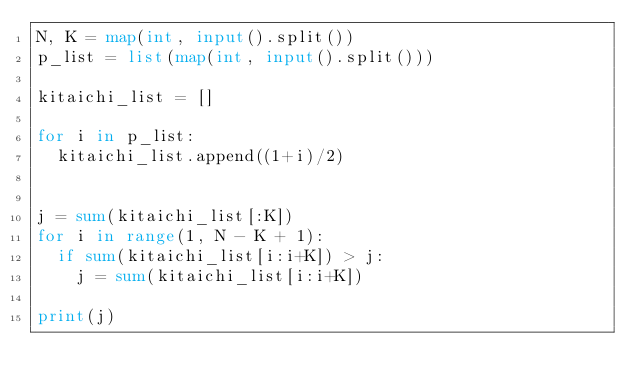Convert code to text. <code><loc_0><loc_0><loc_500><loc_500><_Python_>N, K = map(int, input().split())
p_list = list(map(int, input().split()))

kitaichi_list = []

for i in p_list:
  kitaichi_list.append((1+i)/2)


j = sum(kitaichi_list[:K])
for i in range(1, N - K + 1):
  if sum(kitaichi_list[i:i+K]) > j:
    j = sum(kitaichi_list[i:i+K])

print(j)</code> 